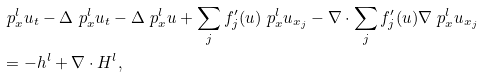Convert formula to latex. <formula><loc_0><loc_0><loc_500><loc_500>& \ p _ { x } ^ { l } u _ { t } - \Delta \ p _ { x } ^ { l } u _ { t } - \Delta \ p _ { x } ^ { l } u + \sum _ { j } f _ { j } ^ { \prime } ( u ) \ p _ { x } ^ { l } u _ { x _ { j } } - \nabla \cdot \sum _ { j } f _ { j } ^ { \prime } ( u ) \nabla \ p _ { x } ^ { l } u _ { x _ { j } } \\ & = - h ^ { l } + \nabla \cdot H ^ { l } ,</formula> 